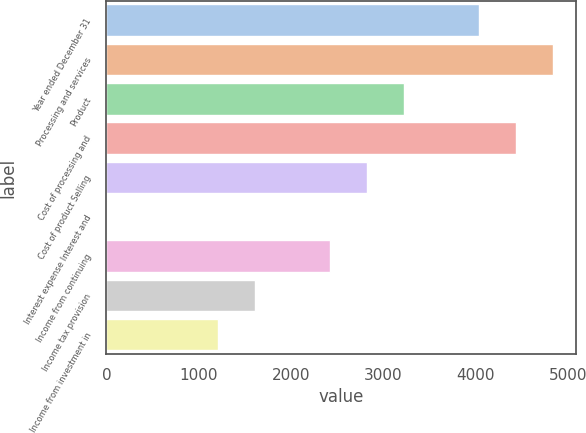<chart> <loc_0><loc_0><loc_500><loc_500><bar_chart><fcel>Year ended December 31<fcel>Processing and services<fcel>Product<fcel>Cost of processing and<fcel>Cost of product Selling<fcel>Interest expense Interest and<fcel>Income from continuing<fcel>Income tax provision<fcel>Income from investment in<nl><fcel>4035<fcel>4841.8<fcel>3228.2<fcel>4438.4<fcel>2824.8<fcel>1<fcel>2421.4<fcel>1614.6<fcel>1211.2<nl></chart> 